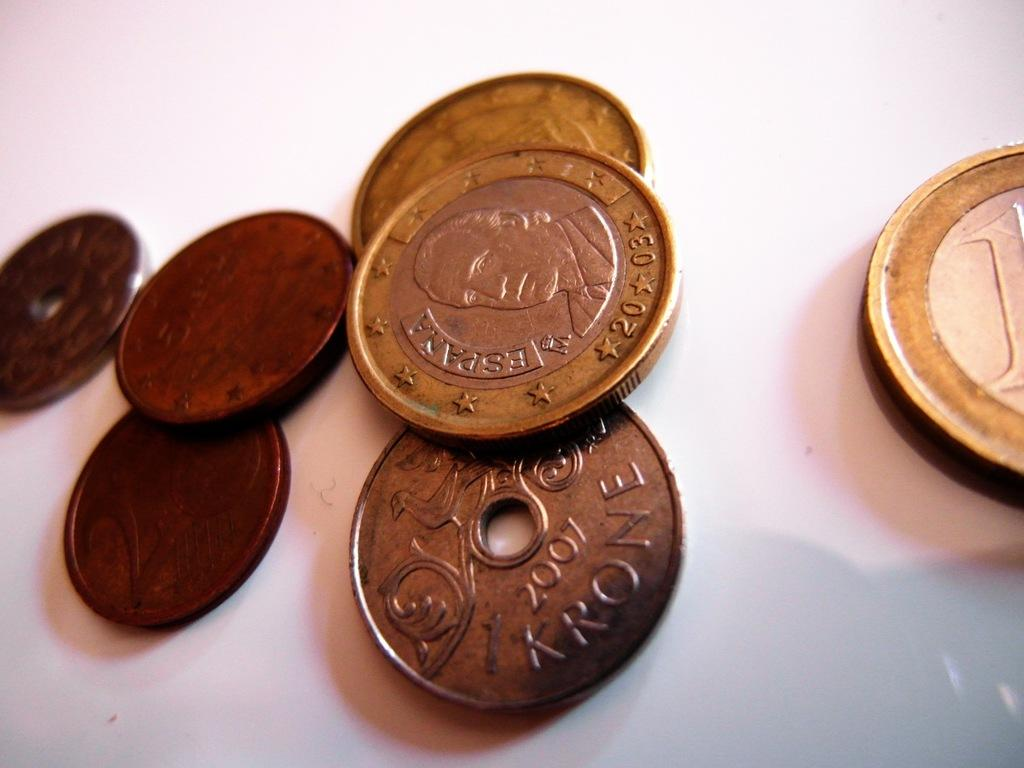<image>
Relay a brief, clear account of the picture shown. A 2007 Krone coin has a hole in the center of it. 